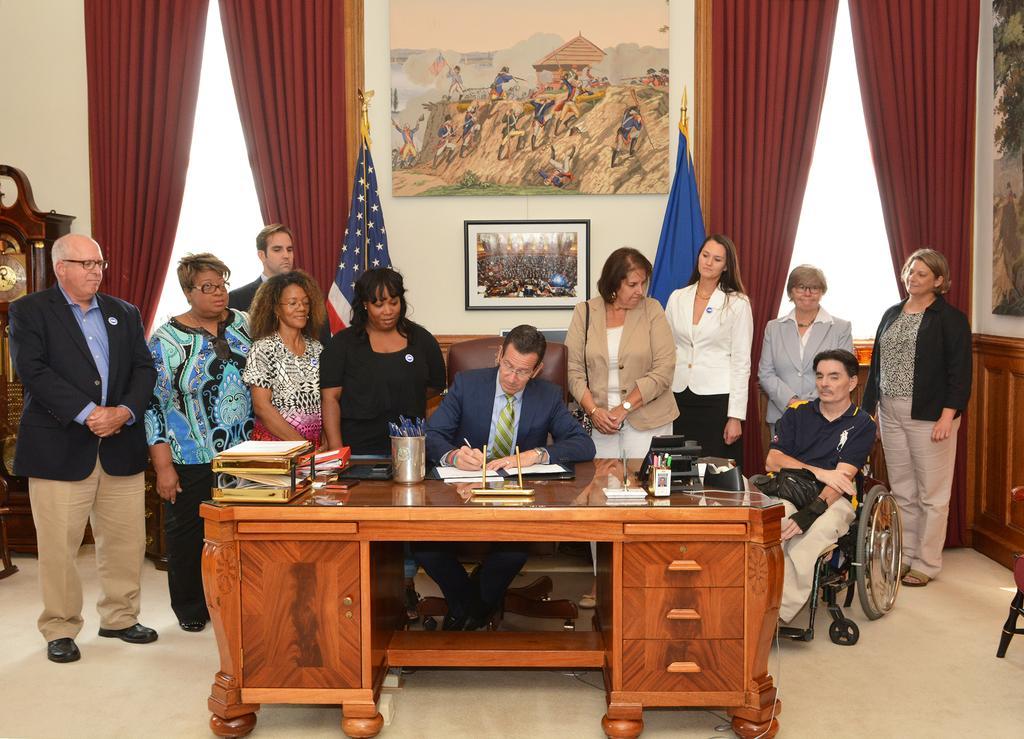Could you give a brief overview of what you see in this image? In this picture there are group of people standing. In the middle there is a man with blue jacket, blue shirt and green tie is sitting on the chair. In front of him there is a table with glass, papers, file, mobile, to the right side there is a telephone, plaster. and to the right side there is a man in the wheelchair. And in the right side top there is a maroon color curtain. And in the middle of the wall there are two frames. And we can see two flags. To the left corner there is a clock. 